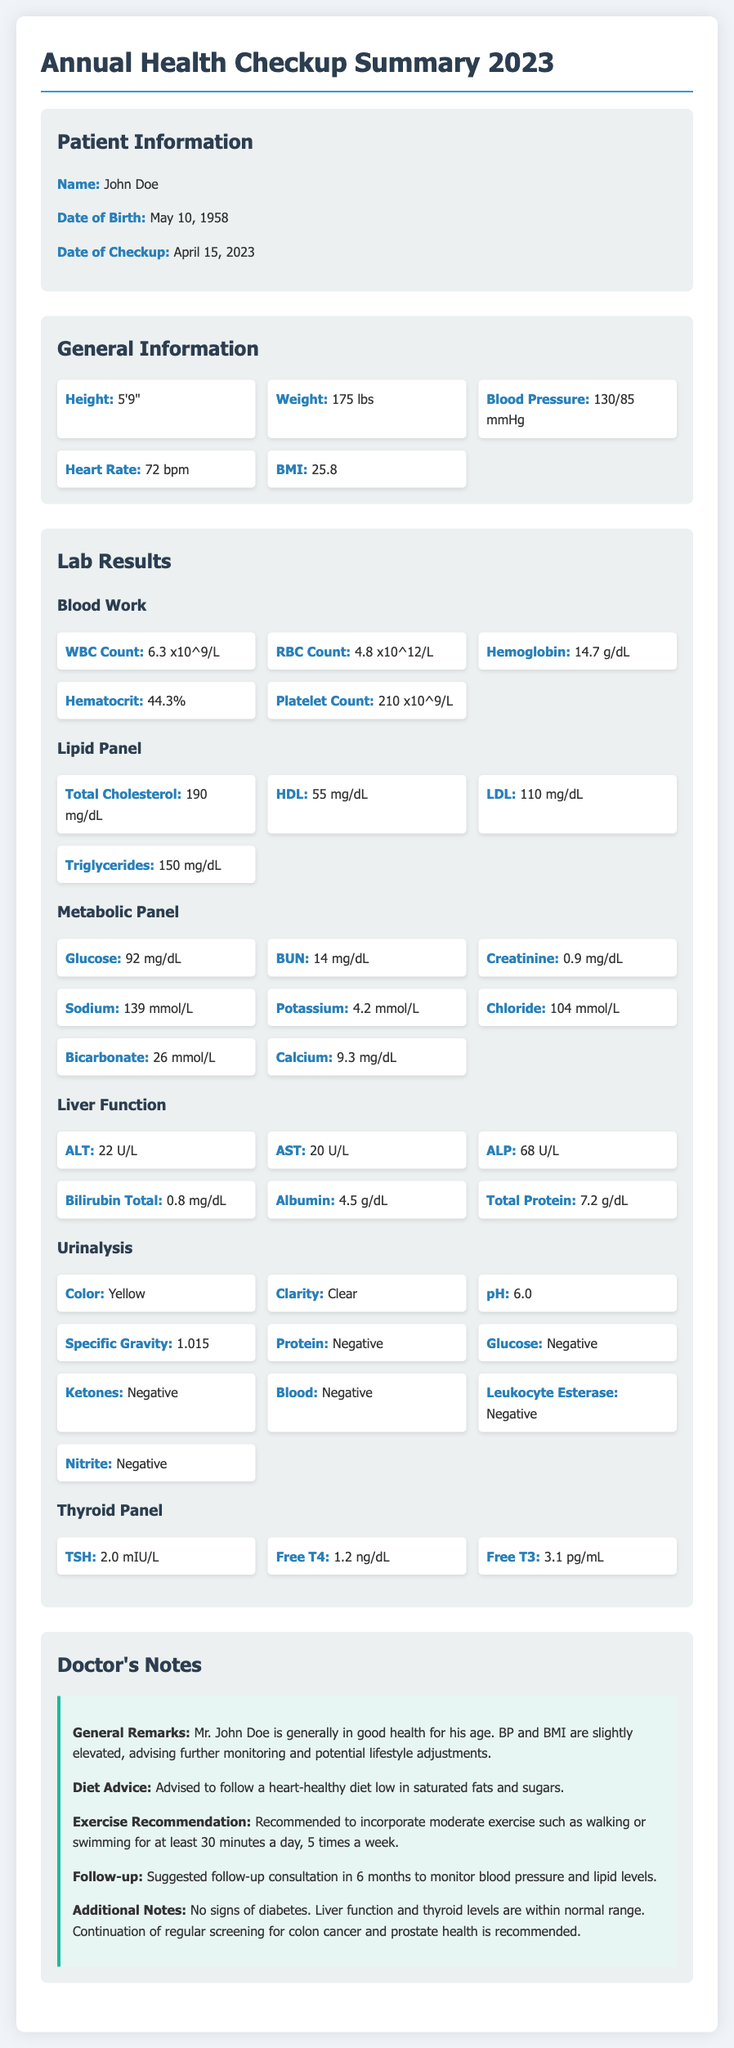What is the patient's name? The patient's name is mentioned at the beginning of the document under Patient Information.
Answer: John Doe What is the date of checkup? The date of the checkup is specified in the Patient Information section.
Answer: April 15, 2023 What is the patient's blood pressure? The blood pressure is noted in the General Information section of the document.
Answer: 130/85 mmHg What is the total cholesterol level? The total cholesterol level is detailed in the Lab Results section under Lipid Panel.
Answer: 190 mg/dL What did the doctor advise regarding exercise? The doctor's exercise recommendation is provided in the Doctor's Notes section.
Answer: Moderate exercise such as walking or swimming for at least 30 minutes a day, 5 times a week Is there any indication of diabetes? The doctor's additional notes discuss signs of diabetes.
Answer: No signs of diabetes What is the BMI reported for the patient? The BMI is listed in the General Information section.
Answer: 25.8 What are the recommended follow-up actions? The follow-up consultation suggestions are provided in the Doctor's Notes section.
Answer: Follow-up consultation in 6 months What level of TSH was recorded? The TSH level is part of the Thyroid Panel in the Lab Results section.
Answer: 2.0 mIU/L 